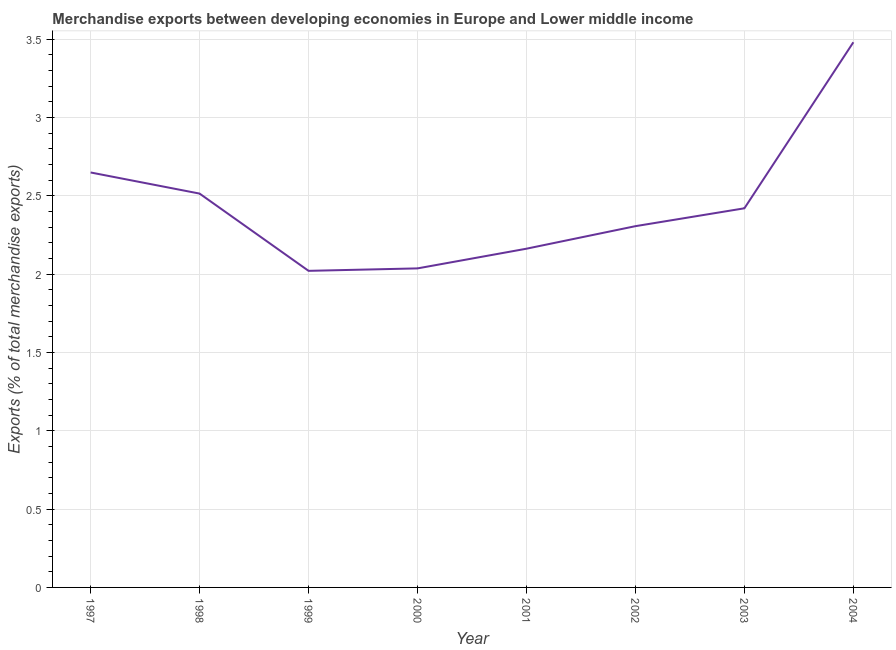What is the merchandise exports in 2004?
Your response must be concise. 3.48. Across all years, what is the maximum merchandise exports?
Provide a short and direct response. 3.48. Across all years, what is the minimum merchandise exports?
Offer a very short reply. 2.02. In which year was the merchandise exports maximum?
Make the answer very short. 2004. In which year was the merchandise exports minimum?
Offer a terse response. 1999. What is the sum of the merchandise exports?
Make the answer very short. 19.59. What is the difference between the merchandise exports in 1999 and 2003?
Provide a short and direct response. -0.4. What is the average merchandise exports per year?
Your response must be concise. 2.45. What is the median merchandise exports?
Offer a very short reply. 2.36. Do a majority of the years between 2004 and 2003 (inclusive) have merchandise exports greater than 3 %?
Your answer should be very brief. No. What is the ratio of the merchandise exports in 1998 to that in 2000?
Your answer should be very brief. 1.23. Is the merchandise exports in 1998 less than that in 2002?
Your answer should be compact. No. Is the difference between the merchandise exports in 1997 and 2004 greater than the difference between any two years?
Offer a terse response. No. What is the difference between the highest and the second highest merchandise exports?
Offer a very short reply. 0.83. What is the difference between the highest and the lowest merchandise exports?
Offer a very short reply. 1.46. Does the merchandise exports monotonically increase over the years?
Your answer should be compact. No. How many lines are there?
Your answer should be compact. 1. Does the graph contain any zero values?
Your answer should be compact. No. Does the graph contain grids?
Ensure brevity in your answer.  Yes. What is the title of the graph?
Your answer should be compact. Merchandise exports between developing economies in Europe and Lower middle income. What is the label or title of the X-axis?
Offer a terse response. Year. What is the label or title of the Y-axis?
Offer a very short reply. Exports (% of total merchandise exports). What is the Exports (% of total merchandise exports) of 1997?
Offer a very short reply. 2.65. What is the Exports (% of total merchandise exports) of 1998?
Provide a succinct answer. 2.51. What is the Exports (% of total merchandise exports) of 1999?
Give a very brief answer. 2.02. What is the Exports (% of total merchandise exports) in 2000?
Keep it short and to the point. 2.04. What is the Exports (% of total merchandise exports) of 2001?
Offer a terse response. 2.16. What is the Exports (% of total merchandise exports) of 2002?
Provide a short and direct response. 2.31. What is the Exports (% of total merchandise exports) in 2003?
Provide a short and direct response. 2.42. What is the Exports (% of total merchandise exports) in 2004?
Your answer should be very brief. 3.48. What is the difference between the Exports (% of total merchandise exports) in 1997 and 1998?
Offer a very short reply. 0.13. What is the difference between the Exports (% of total merchandise exports) in 1997 and 1999?
Provide a succinct answer. 0.63. What is the difference between the Exports (% of total merchandise exports) in 1997 and 2000?
Your answer should be compact. 0.61. What is the difference between the Exports (% of total merchandise exports) in 1997 and 2001?
Provide a short and direct response. 0.49. What is the difference between the Exports (% of total merchandise exports) in 1997 and 2002?
Make the answer very short. 0.34. What is the difference between the Exports (% of total merchandise exports) in 1997 and 2003?
Keep it short and to the point. 0.23. What is the difference between the Exports (% of total merchandise exports) in 1997 and 2004?
Your answer should be very brief. -0.83. What is the difference between the Exports (% of total merchandise exports) in 1998 and 1999?
Keep it short and to the point. 0.49. What is the difference between the Exports (% of total merchandise exports) in 1998 and 2000?
Give a very brief answer. 0.48. What is the difference between the Exports (% of total merchandise exports) in 1998 and 2001?
Offer a very short reply. 0.35. What is the difference between the Exports (% of total merchandise exports) in 1998 and 2002?
Provide a short and direct response. 0.21. What is the difference between the Exports (% of total merchandise exports) in 1998 and 2003?
Provide a succinct answer. 0.09. What is the difference between the Exports (% of total merchandise exports) in 1998 and 2004?
Keep it short and to the point. -0.97. What is the difference between the Exports (% of total merchandise exports) in 1999 and 2000?
Provide a succinct answer. -0.02. What is the difference between the Exports (% of total merchandise exports) in 1999 and 2001?
Make the answer very short. -0.14. What is the difference between the Exports (% of total merchandise exports) in 1999 and 2002?
Make the answer very short. -0.29. What is the difference between the Exports (% of total merchandise exports) in 1999 and 2003?
Make the answer very short. -0.4. What is the difference between the Exports (% of total merchandise exports) in 1999 and 2004?
Your answer should be compact. -1.46. What is the difference between the Exports (% of total merchandise exports) in 2000 and 2001?
Give a very brief answer. -0.13. What is the difference between the Exports (% of total merchandise exports) in 2000 and 2002?
Keep it short and to the point. -0.27. What is the difference between the Exports (% of total merchandise exports) in 2000 and 2003?
Offer a very short reply. -0.38. What is the difference between the Exports (% of total merchandise exports) in 2000 and 2004?
Keep it short and to the point. -1.44. What is the difference between the Exports (% of total merchandise exports) in 2001 and 2002?
Offer a terse response. -0.14. What is the difference between the Exports (% of total merchandise exports) in 2001 and 2003?
Offer a very short reply. -0.26. What is the difference between the Exports (% of total merchandise exports) in 2001 and 2004?
Keep it short and to the point. -1.32. What is the difference between the Exports (% of total merchandise exports) in 2002 and 2003?
Offer a terse response. -0.11. What is the difference between the Exports (% of total merchandise exports) in 2002 and 2004?
Ensure brevity in your answer.  -1.17. What is the difference between the Exports (% of total merchandise exports) in 2003 and 2004?
Keep it short and to the point. -1.06. What is the ratio of the Exports (% of total merchandise exports) in 1997 to that in 1998?
Offer a terse response. 1.05. What is the ratio of the Exports (% of total merchandise exports) in 1997 to that in 1999?
Your answer should be compact. 1.31. What is the ratio of the Exports (% of total merchandise exports) in 1997 to that in 2000?
Give a very brief answer. 1.3. What is the ratio of the Exports (% of total merchandise exports) in 1997 to that in 2001?
Provide a succinct answer. 1.23. What is the ratio of the Exports (% of total merchandise exports) in 1997 to that in 2002?
Make the answer very short. 1.15. What is the ratio of the Exports (% of total merchandise exports) in 1997 to that in 2003?
Provide a short and direct response. 1.09. What is the ratio of the Exports (% of total merchandise exports) in 1997 to that in 2004?
Offer a terse response. 0.76. What is the ratio of the Exports (% of total merchandise exports) in 1998 to that in 1999?
Provide a short and direct response. 1.24. What is the ratio of the Exports (% of total merchandise exports) in 1998 to that in 2000?
Keep it short and to the point. 1.23. What is the ratio of the Exports (% of total merchandise exports) in 1998 to that in 2001?
Your answer should be very brief. 1.16. What is the ratio of the Exports (% of total merchandise exports) in 1998 to that in 2002?
Your answer should be very brief. 1.09. What is the ratio of the Exports (% of total merchandise exports) in 1998 to that in 2003?
Make the answer very short. 1.04. What is the ratio of the Exports (% of total merchandise exports) in 1998 to that in 2004?
Give a very brief answer. 0.72. What is the ratio of the Exports (% of total merchandise exports) in 1999 to that in 2000?
Provide a succinct answer. 0.99. What is the ratio of the Exports (% of total merchandise exports) in 1999 to that in 2001?
Your answer should be very brief. 0.94. What is the ratio of the Exports (% of total merchandise exports) in 1999 to that in 2002?
Your answer should be very brief. 0.88. What is the ratio of the Exports (% of total merchandise exports) in 1999 to that in 2003?
Your response must be concise. 0.83. What is the ratio of the Exports (% of total merchandise exports) in 1999 to that in 2004?
Provide a succinct answer. 0.58. What is the ratio of the Exports (% of total merchandise exports) in 2000 to that in 2001?
Make the answer very short. 0.94. What is the ratio of the Exports (% of total merchandise exports) in 2000 to that in 2002?
Offer a very short reply. 0.88. What is the ratio of the Exports (% of total merchandise exports) in 2000 to that in 2003?
Provide a succinct answer. 0.84. What is the ratio of the Exports (% of total merchandise exports) in 2000 to that in 2004?
Give a very brief answer. 0.58. What is the ratio of the Exports (% of total merchandise exports) in 2001 to that in 2002?
Provide a short and direct response. 0.94. What is the ratio of the Exports (% of total merchandise exports) in 2001 to that in 2003?
Make the answer very short. 0.89. What is the ratio of the Exports (% of total merchandise exports) in 2001 to that in 2004?
Offer a terse response. 0.62. What is the ratio of the Exports (% of total merchandise exports) in 2002 to that in 2003?
Provide a succinct answer. 0.95. What is the ratio of the Exports (% of total merchandise exports) in 2002 to that in 2004?
Your answer should be very brief. 0.66. What is the ratio of the Exports (% of total merchandise exports) in 2003 to that in 2004?
Your answer should be very brief. 0.69. 